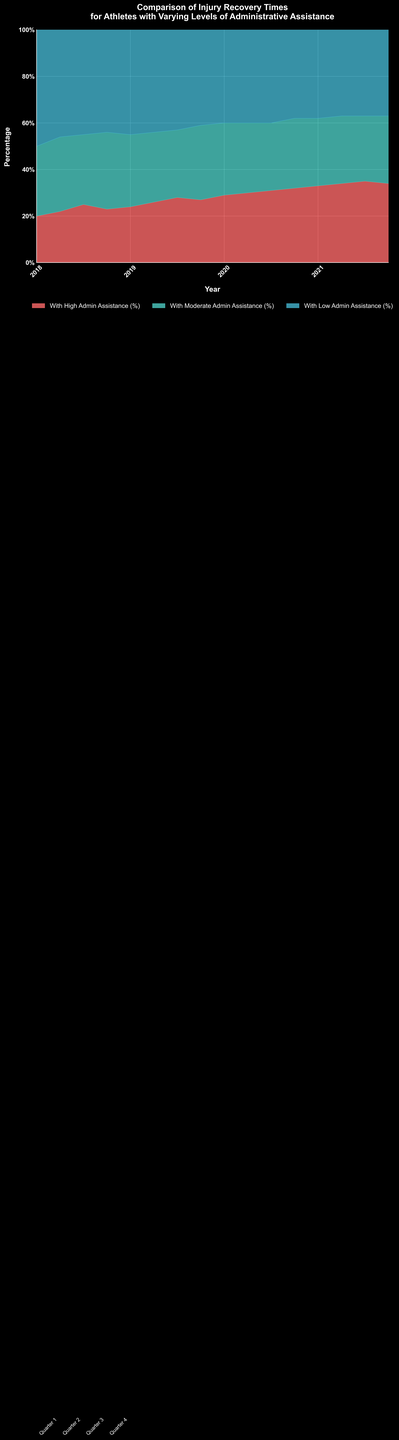What is the title of the chart? The title of the chart is displayed at the top and summarizes the content of the visualization. It states: "Comparison of Injury Recovery Times for Athletes with Varying Levels of Administrative Assistance".
Answer: Comparison of Injury Recovery Times for Athletes with Varying Levels of Administrative Assistance What are the three categories represented in the chart? The chart uses three colors to represent the different categories of administrative assistance: "With High Admin Assistance (%)", "With Moderate Admin Assistance (%)", and "With Low Admin Assistance (%)".
Answer: High Admin Assistance, Moderate Admin Assistance, Low Admin Assistance What percentage of athletes had high admin assistance in Q4 2021? To find this, look at the color band corresponding to "With High Admin Assistance (%)" for the final data point in 2021 Q4. It is shown at the top of the stacked area and the label indicates "34%".
Answer: 34% Which season saw the highest percentage of athletes with low admin assistance? Examine the band for "With Low Admin Assistance (%)" and identify the peak point. The highest percentage is at the beginning, in 2018 Q1, indicated as 50%.
Answer: 2018 Q1 How did the percentage of athletes with moderate admin assistance change from Q1 2020 to Q2 2020? Compare the "With Moderate Admin Assistance (%)" values between Q1 2020 and Q2 2020. The percentage changed from 31% in Q1 2020 to 30% in Q2 2020, showing a 1% decrease.
Answer: Decreased by 1% In which quarter did the percentage of athletes with high admin assistance first surpass 30%? Find the first instance where the "With High Admin Assistance (%)" band passes the 30% level. This occurs in Q2 2020 where it reached 30%.
Answer: Q2 2020 What is the general trend for athletes with low admin assistance from 2018 to 2021? Observe the "With Low Admin Assistance (%)" section over time, noting the trend. It starts high at 50% in 2018 Q1 and generally declines to around 37% by the end of 2021.
Answer: Decreasing trend What is the combined percentage of athletes with high and moderate admin assistance in Q3 2021? Add the percentages for "With High Admin Assistance (%)" and "With Moderate Admin Assistance (%)" in Q3 2021: 35% + 28% = 63%.
Answer: 63% Which year showed the greatest variation in the percentage of athletes with moderate admin assistance? Look at the spread of values for "With Moderate Admin Assistance (%)" across different years. In 2018, the values varied from 30% to 33%, a 3% range, which is the most fluctuating year for this category.
Answer: 2018 What's the difference in percentage points between athletes with high admin assistance and those with low admin assistance in Q4 2020? Calculate the difference by subtracting the percentage of "With Low Admin Assistance (%)" from "With High Admin Assistance (%)" in Q4 2020: 32% - 38% = -6%.
Answer: -6% 